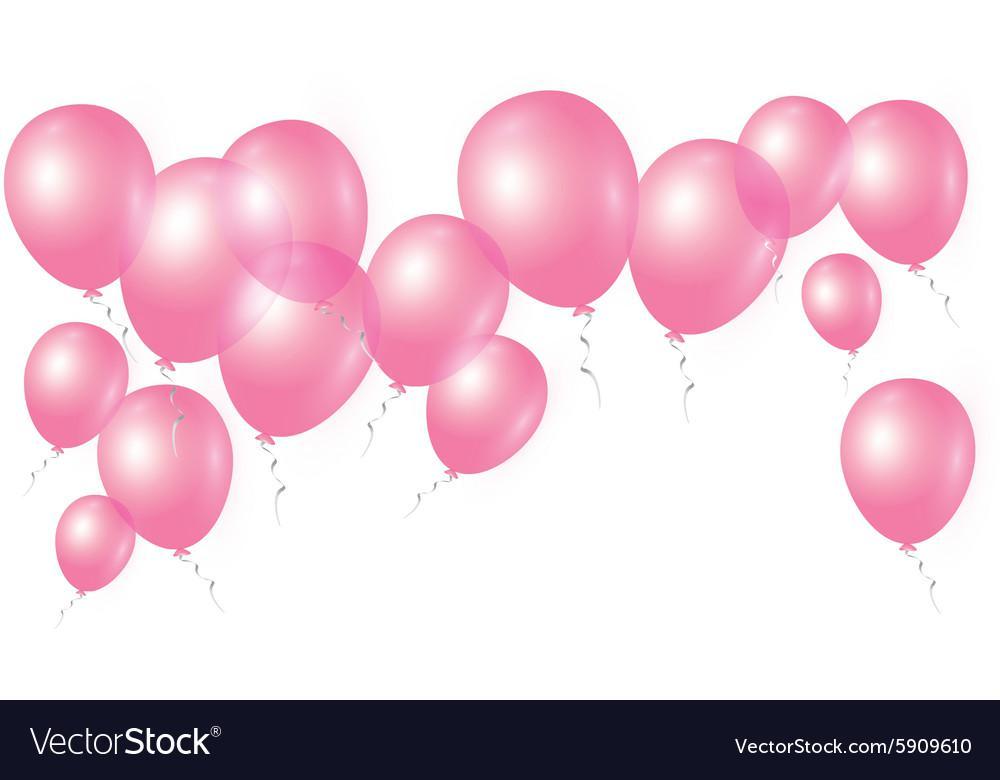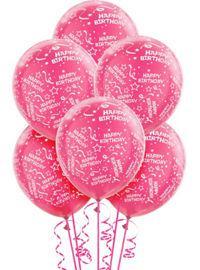The first image is the image on the left, the second image is the image on the right. For the images displayed, is the sentence "There are more balloons in the image on the left." factually correct? Answer yes or no. Yes. The first image is the image on the left, the second image is the image on the right. Analyze the images presented: Is the assertion "There are no less than 19 balloons." valid? Answer yes or no. Yes. 